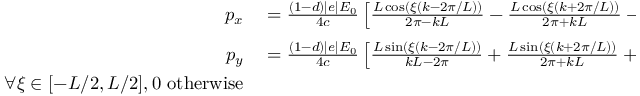<formula> <loc_0><loc_0><loc_500><loc_500>\begin{array} { r l } { p _ { x } } & = \frac { ( 1 - d ) | e | E _ { 0 } } { 4 c } \left [ \frac { L \cos ( \xi ( k - 2 \pi / L ) ) } { 2 \pi - k L } - \frac { L \cos ( \xi ( k + 2 \pi / L ) ) } { 2 \pi + k L } - \frac { 2 \cos ( k \xi ) } { k } \right ] _ { \xi ^ { \prime } } ^ { \xi ^ { \prime } - \phi } } \\ { p _ { y } } & = \frac { ( 1 - d ) | e | E _ { 0 } } { 4 c } \left [ \frac { L \sin ( \xi ( k - 2 \pi / L ) ) } { k L - 2 \pi } + \frac { L \sin ( \xi ( k + 2 \pi / L ) ) } { 2 \pi + k L } + \frac { 2 \sin ( k \xi ) } { k } \right ] _ { \xi ^ { \prime } } ^ { \xi ^ { \prime } - \phi } } \\ { \forall \xi \in [ - L / 2 , L / 2 ] , 0 \ o t h e r w i s e } \end{array}</formula> 